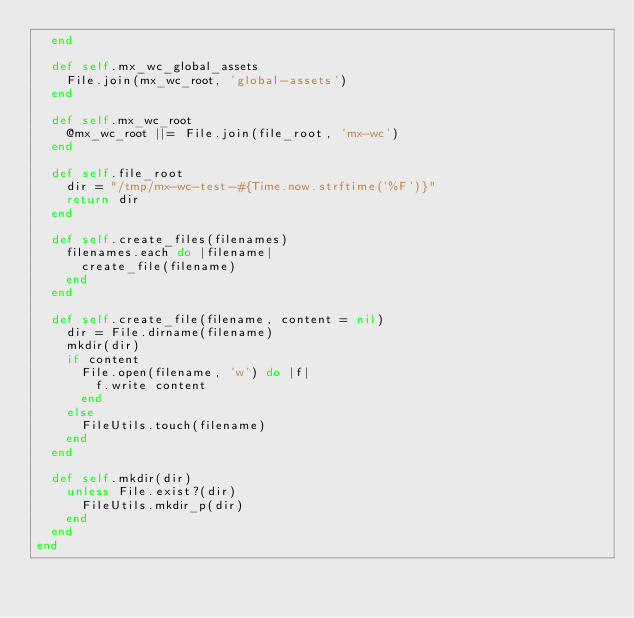Convert code to text. <code><loc_0><loc_0><loc_500><loc_500><_Ruby_>  end

  def self.mx_wc_global_assets
    File.join(mx_wc_root, 'global-assets')
  end

  def self.mx_wc_root
    @mx_wc_root ||= File.join(file_root, 'mx-wc')
  end

  def self.file_root
    dir = "/tmp/mx-wc-test-#{Time.now.strftime('%F')}"
    return dir
  end

  def self.create_files(filenames)
    filenames.each do |filename|
      create_file(filename)
    end
  end

  def self.create_file(filename, content = nil)
    dir = File.dirname(filename)
    mkdir(dir)
    if content
      File.open(filename, 'w') do |f|
        f.write content
      end
    else
      FileUtils.touch(filename)
    end
  end

  def self.mkdir(dir)
    unless File.exist?(dir)
      FileUtils.mkdir_p(dir)
    end
  end
end
</code> 